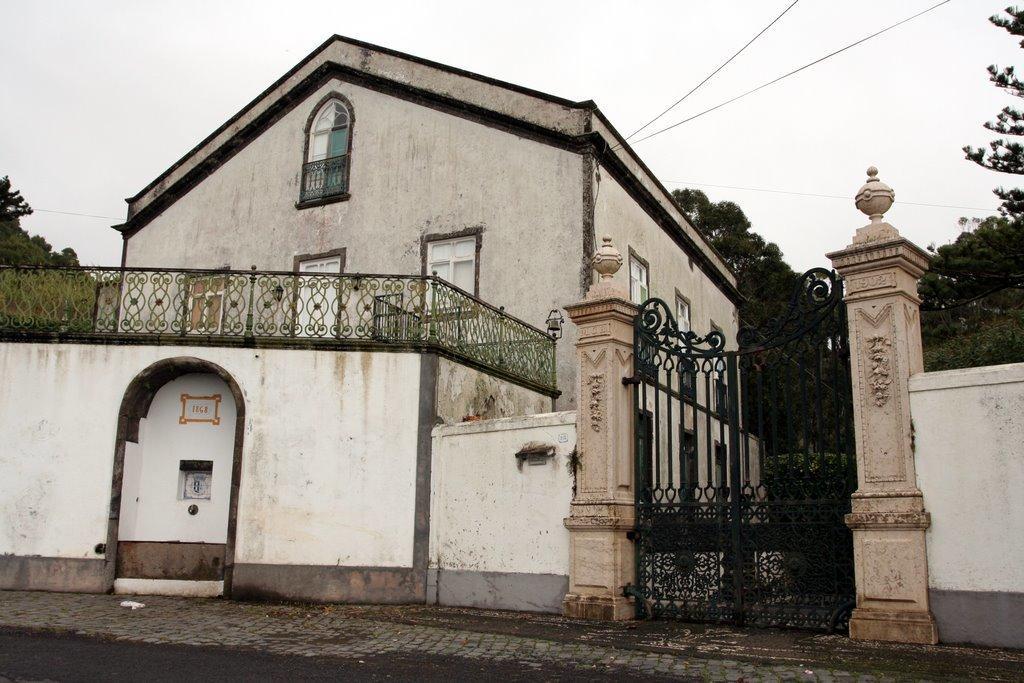How would you summarize this image in a sentence or two? This is the picture of an old house with white painting and beside to the house there is a gate and the entrance to the house. The house has the balcony with a door and windows. In front of the house there is a road. In background there is a sky and the trees. 